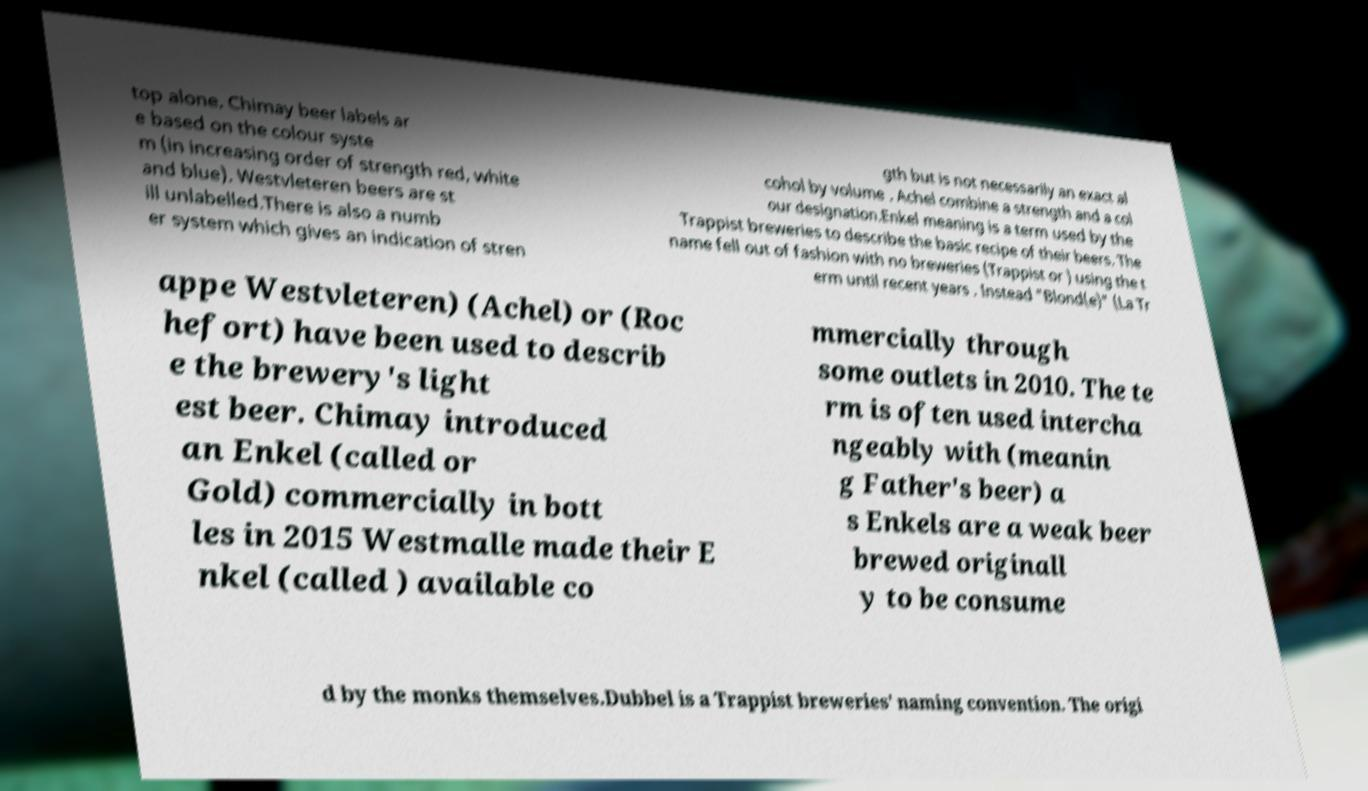Please identify and transcribe the text found in this image. top alone. Chimay beer labels ar e based on the colour syste m (in increasing order of strength red, white and blue). Westvleteren beers are st ill unlabelled.There is also a numb er system which gives an indication of stren gth but is not necessarily an exact al cohol by volume . Achel combine a strength and a col our designation.Enkel meaning is a term used by the Trappist breweries to describe the basic recipe of their beers. The name fell out of fashion with no breweries (Trappist or ) using the t erm until recent years . Instead "Blond(e)" (La Tr appe Westvleteren) (Achel) or (Roc hefort) have been used to describ e the brewery's light est beer. Chimay introduced an Enkel (called or Gold) commercially in bott les in 2015 Westmalle made their E nkel (called ) available co mmercially through some outlets in 2010. The te rm is often used intercha ngeably with (meanin g Father's beer) a s Enkels are a weak beer brewed originall y to be consume d by the monks themselves.Dubbel is a Trappist breweries' naming convention. The origi 